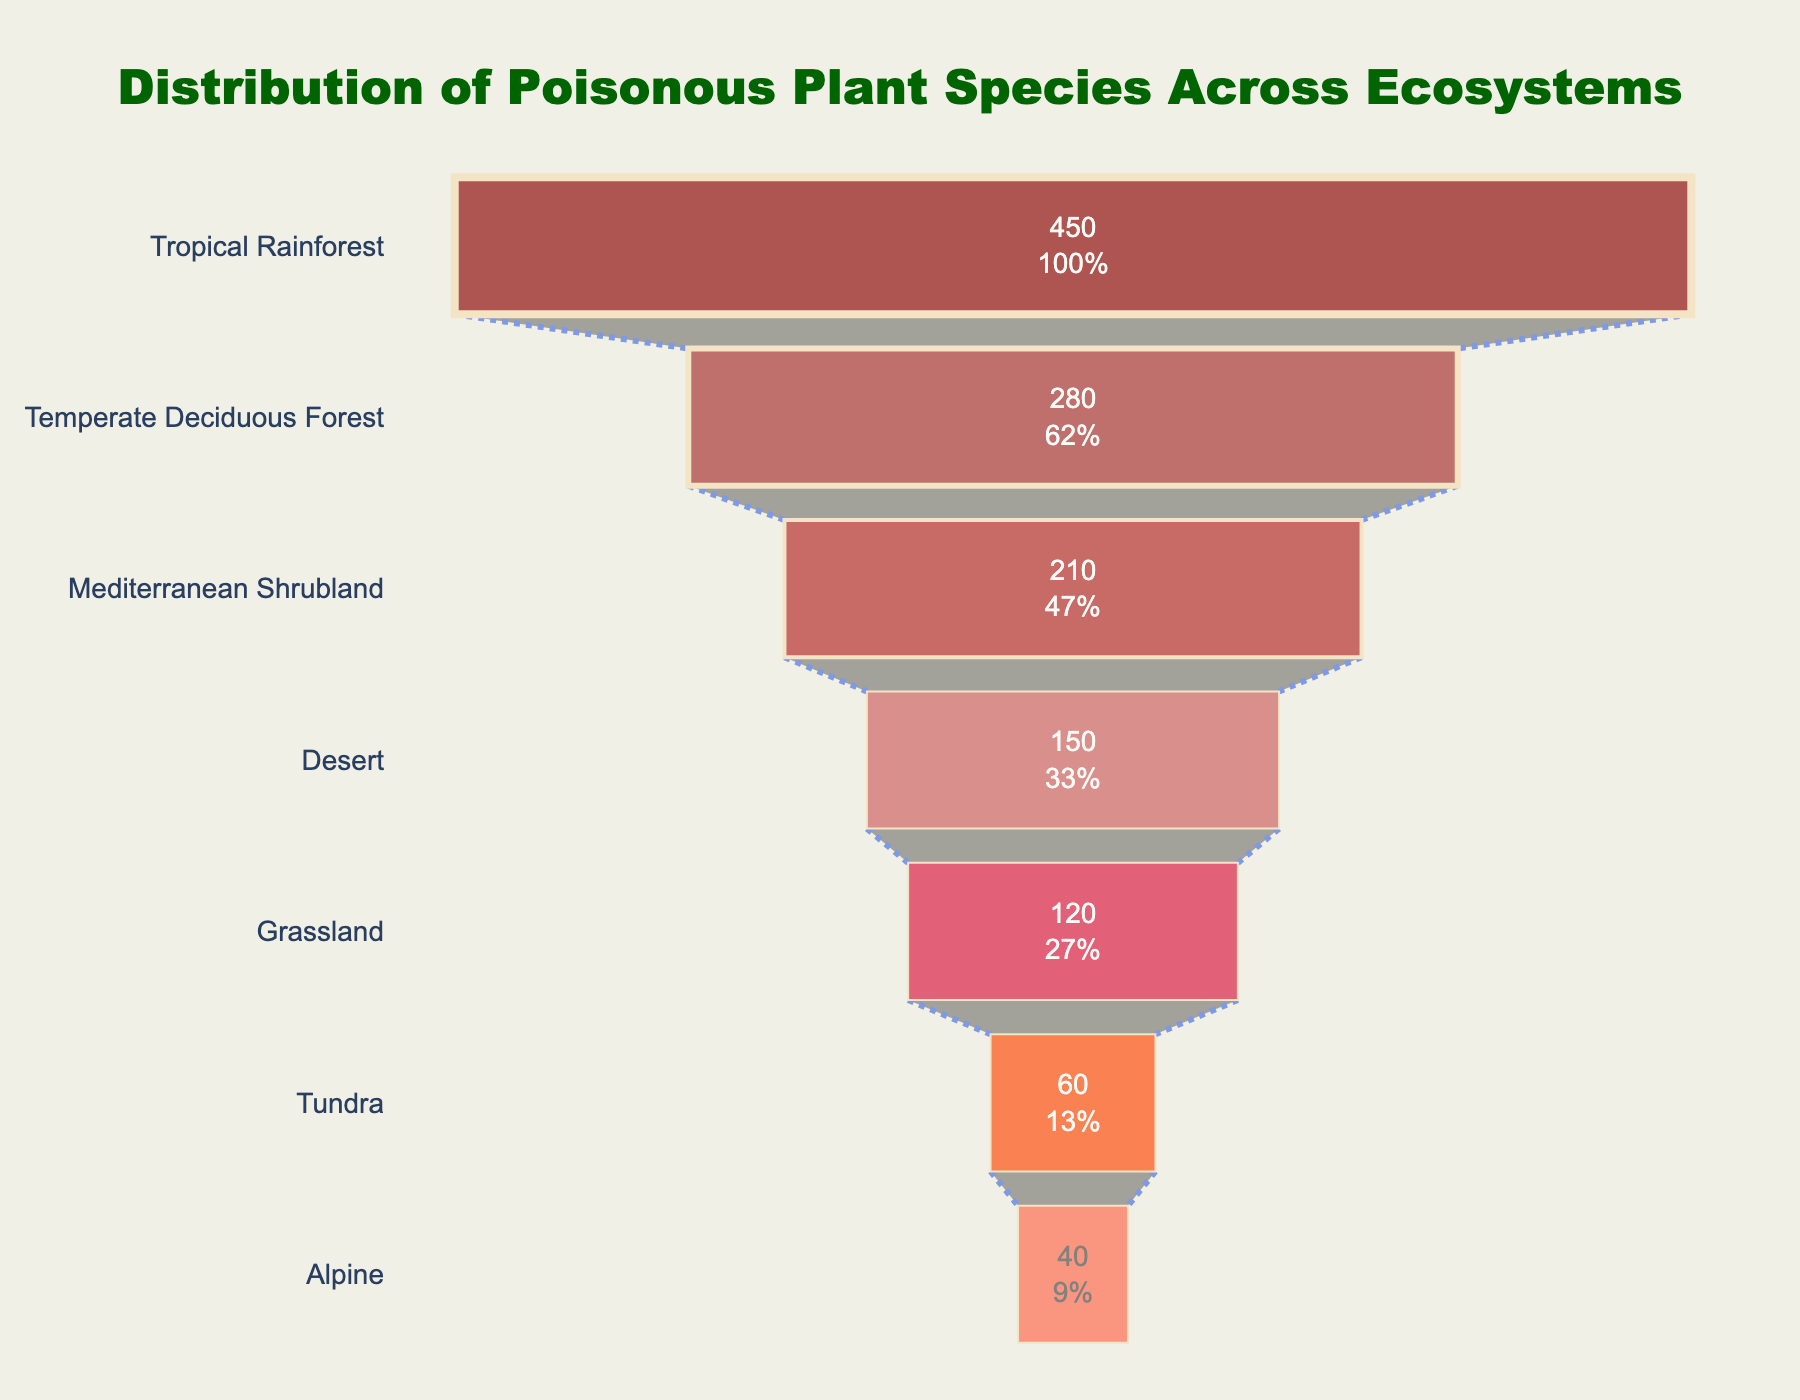What is the ecosystem with the highest number of poisonous plant species? By looking at the top of the funnel chart, we can see that the Tropical Rainforest has the highest value.
Answer: Tropical Rainforest How many poisonous plant species are there in the Desert ecosystem? At the fourth position from the top of the funnel chart, the Desert ecosystem shows 150 species.
Answer: 150 What is the combined number of poisonous plant species in Grassland and Tundra ecosystems? Summing the values for Grassland (120) and Tundra (60) gives 120 + 60 = 180.
Answer: 180 Which ecosystem has fewer poisonous plant species: Mediterranean Shrubland or Alpine? Mediterranean Shrubland has 210 species, while Alpine has 40 species, so Alpine has fewer.
Answer: Alpine How many ecosystems have more than 200 poisonous plant species? Count the ecosystems with values greater than 200: Tropical Rainforest (450), Temperate Deciduous Forest (280), and Mediterranean Shrubland (210). There are 3 such ecosystems.
Answer: 3 What is the difference in the number of poisonous plant species between the ecosystem with the most species and the ecosystem with the least species? Tropical Rainforest has 450 species, and Alpine has 40 species. The difference is 450 - 40 = 410.
Answer: 410 Which ecosystem shows the third highest number of poisonous plant species? The third segment from the top shows Mediterranean Shrubland with 210 species.
Answer: Mediterranean Shrubland What is the total number of poisonous plant species across all ecosystems? Sum all the numbers: 450 + 280 + 210 + 150 + 120 + 60 + 40 = 1310.
Answer: 1310 How does the number of poisonous plant species in the Tundra compare to those in the Alpine ecosystem? The Tundra has 60 species, while the Alpine has 40, so the Tundra has more species.
Answer: Tundra What percentage of all poisonous plant species belong to the Tropical Rainforest ecosystem? The total number of species is 1310. The Tropical Rainforest has 450 species. The percentage is (450 / 1310) * 100 ≈ 34.35%.
Answer: 34.35% 